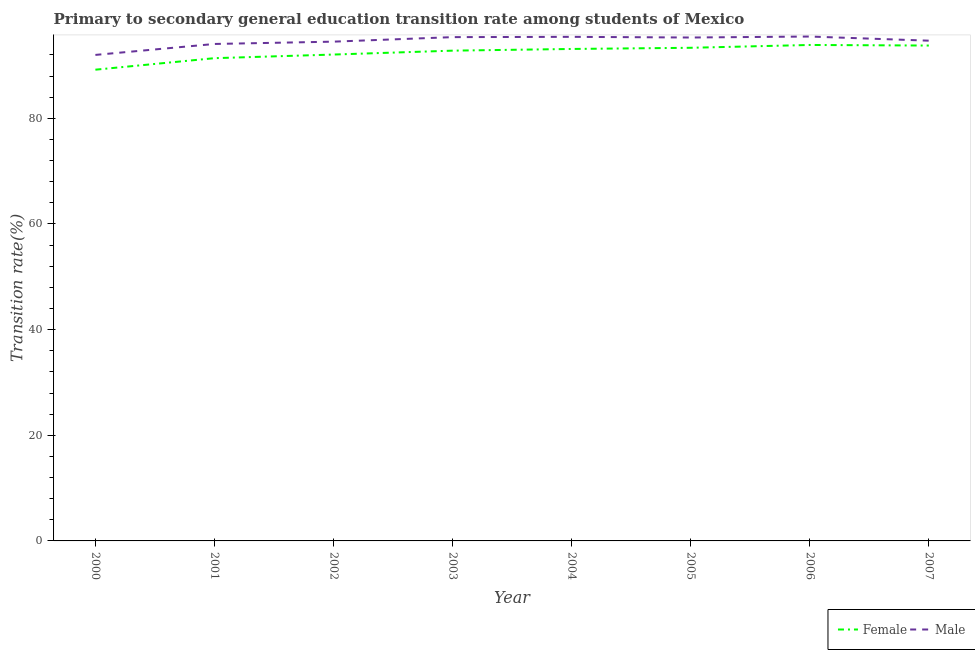Does the line corresponding to transition rate among male students intersect with the line corresponding to transition rate among female students?
Ensure brevity in your answer.  No. What is the transition rate among female students in 2001?
Provide a succinct answer. 91.39. Across all years, what is the maximum transition rate among female students?
Offer a terse response. 93.89. Across all years, what is the minimum transition rate among female students?
Provide a succinct answer. 89.21. In which year was the transition rate among male students maximum?
Give a very brief answer. 2006. What is the total transition rate among female students in the graph?
Ensure brevity in your answer.  739.67. What is the difference between the transition rate among female students in 2004 and that in 2007?
Provide a succinct answer. -0.65. What is the difference between the transition rate among male students in 2004 and the transition rate among female students in 2001?
Your answer should be very brief. 4.04. What is the average transition rate among male students per year?
Provide a succinct answer. 94.61. In the year 2000, what is the difference between the transition rate among female students and transition rate among male students?
Your response must be concise. -2.8. What is the ratio of the transition rate among female students in 2002 to that in 2005?
Offer a very short reply. 0.99. Is the difference between the transition rate among female students in 2004 and 2007 greater than the difference between the transition rate among male students in 2004 and 2007?
Ensure brevity in your answer.  No. What is the difference between the highest and the second highest transition rate among male students?
Your answer should be compact. 0.06. What is the difference between the highest and the lowest transition rate among female students?
Provide a succinct answer. 4.68. In how many years, is the transition rate among male students greater than the average transition rate among male students taken over all years?
Give a very brief answer. 5. Does the transition rate among female students monotonically increase over the years?
Your answer should be compact. No. What is the difference between two consecutive major ticks on the Y-axis?
Give a very brief answer. 20. Does the graph contain grids?
Your answer should be very brief. No. Where does the legend appear in the graph?
Keep it short and to the point. Bottom right. How many legend labels are there?
Make the answer very short. 2. What is the title of the graph?
Keep it short and to the point. Primary to secondary general education transition rate among students of Mexico. Does "Secondary" appear as one of the legend labels in the graph?
Provide a succinct answer. No. What is the label or title of the X-axis?
Keep it short and to the point. Year. What is the label or title of the Y-axis?
Offer a very short reply. Transition rate(%). What is the Transition rate(%) of Female in 2000?
Ensure brevity in your answer.  89.21. What is the Transition rate(%) in Male in 2000?
Provide a succinct answer. 92.01. What is the Transition rate(%) in Female in 2001?
Make the answer very short. 91.39. What is the Transition rate(%) in Male in 2001?
Give a very brief answer. 94.08. What is the Transition rate(%) in Female in 2002?
Provide a short and direct response. 92.08. What is the Transition rate(%) in Male in 2002?
Keep it short and to the point. 94.52. What is the Transition rate(%) in Female in 2003?
Ensure brevity in your answer.  92.82. What is the Transition rate(%) in Male in 2003?
Provide a short and direct response. 95.38. What is the Transition rate(%) in Female in 2004?
Ensure brevity in your answer.  93.14. What is the Transition rate(%) in Male in 2004?
Your answer should be compact. 95.43. What is the Transition rate(%) in Female in 2005?
Ensure brevity in your answer.  93.36. What is the Transition rate(%) of Male in 2005?
Offer a terse response. 95.3. What is the Transition rate(%) in Female in 2006?
Ensure brevity in your answer.  93.89. What is the Transition rate(%) of Male in 2006?
Your answer should be compact. 95.49. What is the Transition rate(%) in Female in 2007?
Your response must be concise. 93.78. What is the Transition rate(%) in Male in 2007?
Make the answer very short. 94.7. Across all years, what is the maximum Transition rate(%) in Female?
Give a very brief answer. 93.89. Across all years, what is the maximum Transition rate(%) of Male?
Provide a succinct answer. 95.49. Across all years, what is the minimum Transition rate(%) in Female?
Your answer should be very brief. 89.21. Across all years, what is the minimum Transition rate(%) in Male?
Your response must be concise. 92.01. What is the total Transition rate(%) in Female in the graph?
Offer a very short reply. 739.66. What is the total Transition rate(%) of Male in the graph?
Your answer should be very brief. 756.91. What is the difference between the Transition rate(%) in Female in 2000 and that in 2001?
Make the answer very short. -2.18. What is the difference between the Transition rate(%) of Male in 2000 and that in 2001?
Your answer should be very brief. -2.07. What is the difference between the Transition rate(%) in Female in 2000 and that in 2002?
Provide a short and direct response. -2.87. What is the difference between the Transition rate(%) in Male in 2000 and that in 2002?
Provide a short and direct response. -2.51. What is the difference between the Transition rate(%) in Female in 2000 and that in 2003?
Ensure brevity in your answer.  -3.6. What is the difference between the Transition rate(%) of Male in 2000 and that in 2003?
Your response must be concise. -3.37. What is the difference between the Transition rate(%) of Female in 2000 and that in 2004?
Give a very brief answer. -3.92. What is the difference between the Transition rate(%) of Male in 2000 and that in 2004?
Your response must be concise. -3.42. What is the difference between the Transition rate(%) of Female in 2000 and that in 2005?
Offer a very short reply. -4.15. What is the difference between the Transition rate(%) in Male in 2000 and that in 2005?
Your answer should be very brief. -3.29. What is the difference between the Transition rate(%) of Female in 2000 and that in 2006?
Your response must be concise. -4.68. What is the difference between the Transition rate(%) in Male in 2000 and that in 2006?
Keep it short and to the point. -3.48. What is the difference between the Transition rate(%) in Female in 2000 and that in 2007?
Your response must be concise. -4.57. What is the difference between the Transition rate(%) in Male in 2000 and that in 2007?
Ensure brevity in your answer.  -2.69. What is the difference between the Transition rate(%) in Female in 2001 and that in 2002?
Offer a terse response. -0.69. What is the difference between the Transition rate(%) of Male in 2001 and that in 2002?
Your answer should be compact. -0.44. What is the difference between the Transition rate(%) in Female in 2001 and that in 2003?
Offer a very short reply. -1.42. What is the difference between the Transition rate(%) in Male in 2001 and that in 2003?
Make the answer very short. -1.29. What is the difference between the Transition rate(%) in Female in 2001 and that in 2004?
Give a very brief answer. -1.74. What is the difference between the Transition rate(%) in Male in 2001 and that in 2004?
Offer a very short reply. -1.35. What is the difference between the Transition rate(%) in Female in 2001 and that in 2005?
Provide a succinct answer. -1.97. What is the difference between the Transition rate(%) of Male in 2001 and that in 2005?
Offer a terse response. -1.22. What is the difference between the Transition rate(%) in Female in 2001 and that in 2006?
Ensure brevity in your answer.  -2.5. What is the difference between the Transition rate(%) in Male in 2001 and that in 2006?
Offer a very short reply. -1.41. What is the difference between the Transition rate(%) of Female in 2001 and that in 2007?
Ensure brevity in your answer.  -2.39. What is the difference between the Transition rate(%) of Male in 2001 and that in 2007?
Offer a very short reply. -0.62. What is the difference between the Transition rate(%) of Female in 2002 and that in 2003?
Your answer should be compact. -0.74. What is the difference between the Transition rate(%) of Male in 2002 and that in 2003?
Make the answer very short. -0.86. What is the difference between the Transition rate(%) in Female in 2002 and that in 2004?
Give a very brief answer. -1.06. What is the difference between the Transition rate(%) of Male in 2002 and that in 2004?
Your response must be concise. -0.91. What is the difference between the Transition rate(%) of Female in 2002 and that in 2005?
Your answer should be compact. -1.28. What is the difference between the Transition rate(%) of Male in 2002 and that in 2005?
Make the answer very short. -0.78. What is the difference between the Transition rate(%) in Female in 2002 and that in 2006?
Offer a very short reply. -1.81. What is the difference between the Transition rate(%) of Male in 2002 and that in 2006?
Make the answer very short. -0.97. What is the difference between the Transition rate(%) in Female in 2002 and that in 2007?
Give a very brief answer. -1.7. What is the difference between the Transition rate(%) of Male in 2002 and that in 2007?
Give a very brief answer. -0.18. What is the difference between the Transition rate(%) in Female in 2003 and that in 2004?
Your answer should be very brief. -0.32. What is the difference between the Transition rate(%) in Male in 2003 and that in 2004?
Keep it short and to the point. -0.05. What is the difference between the Transition rate(%) of Female in 2003 and that in 2005?
Keep it short and to the point. -0.54. What is the difference between the Transition rate(%) in Male in 2003 and that in 2005?
Provide a succinct answer. 0.07. What is the difference between the Transition rate(%) in Female in 2003 and that in 2006?
Your response must be concise. -1.08. What is the difference between the Transition rate(%) in Male in 2003 and that in 2006?
Ensure brevity in your answer.  -0.11. What is the difference between the Transition rate(%) in Female in 2003 and that in 2007?
Ensure brevity in your answer.  -0.97. What is the difference between the Transition rate(%) of Male in 2003 and that in 2007?
Give a very brief answer. 0.67. What is the difference between the Transition rate(%) of Female in 2004 and that in 2005?
Provide a short and direct response. -0.22. What is the difference between the Transition rate(%) of Male in 2004 and that in 2005?
Offer a very short reply. 0.13. What is the difference between the Transition rate(%) of Female in 2004 and that in 2006?
Give a very brief answer. -0.76. What is the difference between the Transition rate(%) in Male in 2004 and that in 2006?
Provide a short and direct response. -0.06. What is the difference between the Transition rate(%) in Female in 2004 and that in 2007?
Offer a terse response. -0.65. What is the difference between the Transition rate(%) in Male in 2004 and that in 2007?
Your answer should be compact. 0.73. What is the difference between the Transition rate(%) in Female in 2005 and that in 2006?
Offer a very short reply. -0.53. What is the difference between the Transition rate(%) in Male in 2005 and that in 2006?
Your answer should be very brief. -0.19. What is the difference between the Transition rate(%) in Female in 2005 and that in 2007?
Make the answer very short. -0.42. What is the difference between the Transition rate(%) in Male in 2005 and that in 2007?
Your answer should be very brief. 0.6. What is the difference between the Transition rate(%) in Female in 2006 and that in 2007?
Offer a terse response. 0.11. What is the difference between the Transition rate(%) of Male in 2006 and that in 2007?
Provide a succinct answer. 0.78. What is the difference between the Transition rate(%) of Female in 2000 and the Transition rate(%) of Male in 2001?
Your answer should be very brief. -4.87. What is the difference between the Transition rate(%) of Female in 2000 and the Transition rate(%) of Male in 2002?
Your answer should be compact. -5.31. What is the difference between the Transition rate(%) in Female in 2000 and the Transition rate(%) in Male in 2003?
Ensure brevity in your answer.  -6.16. What is the difference between the Transition rate(%) in Female in 2000 and the Transition rate(%) in Male in 2004?
Make the answer very short. -6.22. What is the difference between the Transition rate(%) in Female in 2000 and the Transition rate(%) in Male in 2005?
Ensure brevity in your answer.  -6.09. What is the difference between the Transition rate(%) in Female in 2000 and the Transition rate(%) in Male in 2006?
Your answer should be very brief. -6.28. What is the difference between the Transition rate(%) of Female in 2000 and the Transition rate(%) of Male in 2007?
Offer a terse response. -5.49. What is the difference between the Transition rate(%) of Female in 2001 and the Transition rate(%) of Male in 2002?
Provide a succinct answer. -3.13. What is the difference between the Transition rate(%) of Female in 2001 and the Transition rate(%) of Male in 2003?
Your answer should be very brief. -3.98. What is the difference between the Transition rate(%) in Female in 2001 and the Transition rate(%) in Male in 2004?
Your response must be concise. -4.04. What is the difference between the Transition rate(%) in Female in 2001 and the Transition rate(%) in Male in 2005?
Keep it short and to the point. -3.91. What is the difference between the Transition rate(%) of Female in 2001 and the Transition rate(%) of Male in 2006?
Your answer should be very brief. -4.1. What is the difference between the Transition rate(%) of Female in 2001 and the Transition rate(%) of Male in 2007?
Your answer should be compact. -3.31. What is the difference between the Transition rate(%) of Female in 2002 and the Transition rate(%) of Male in 2003?
Offer a very short reply. -3.3. What is the difference between the Transition rate(%) of Female in 2002 and the Transition rate(%) of Male in 2004?
Offer a terse response. -3.35. What is the difference between the Transition rate(%) in Female in 2002 and the Transition rate(%) in Male in 2005?
Your answer should be very brief. -3.22. What is the difference between the Transition rate(%) of Female in 2002 and the Transition rate(%) of Male in 2006?
Offer a terse response. -3.41. What is the difference between the Transition rate(%) of Female in 2002 and the Transition rate(%) of Male in 2007?
Your answer should be compact. -2.63. What is the difference between the Transition rate(%) in Female in 2003 and the Transition rate(%) in Male in 2004?
Keep it short and to the point. -2.61. What is the difference between the Transition rate(%) of Female in 2003 and the Transition rate(%) of Male in 2005?
Keep it short and to the point. -2.49. What is the difference between the Transition rate(%) in Female in 2003 and the Transition rate(%) in Male in 2006?
Make the answer very short. -2.67. What is the difference between the Transition rate(%) in Female in 2003 and the Transition rate(%) in Male in 2007?
Make the answer very short. -1.89. What is the difference between the Transition rate(%) of Female in 2004 and the Transition rate(%) of Male in 2005?
Ensure brevity in your answer.  -2.17. What is the difference between the Transition rate(%) of Female in 2004 and the Transition rate(%) of Male in 2006?
Give a very brief answer. -2.35. What is the difference between the Transition rate(%) of Female in 2004 and the Transition rate(%) of Male in 2007?
Provide a succinct answer. -1.57. What is the difference between the Transition rate(%) of Female in 2005 and the Transition rate(%) of Male in 2006?
Give a very brief answer. -2.13. What is the difference between the Transition rate(%) in Female in 2005 and the Transition rate(%) in Male in 2007?
Provide a short and direct response. -1.35. What is the difference between the Transition rate(%) in Female in 2006 and the Transition rate(%) in Male in 2007?
Provide a short and direct response. -0.81. What is the average Transition rate(%) in Female per year?
Ensure brevity in your answer.  92.46. What is the average Transition rate(%) of Male per year?
Your answer should be very brief. 94.61. In the year 2000, what is the difference between the Transition rate(%) of Female and Transition rate(%) of Male?
Your response must be concise. -2.8. In the year 2001, what is the difference between the Transition rate(%) in Female and Transition rate(%) in Male?
Your answer should be compact. -2.69. In the year 2002, what is the difference between the Transition rate(%) of Female and Transition rate(%) of Male?
Offer a terse response. -2.44. In the year 2003, what is the difference between the Transition rate(%) of Female and Transition rate(%) of Male?
Keep it short and to the point. -2.56. In the year 2004, what is the difference between the Transition rate(%) of Female and Transition rate(%) of Male?
Provide a short and direct response. -2.29. In the year 2005, what is the difference between the Transition rate(%) in Female and Transition rate(%) in Male?
Offer a very short reply. -1.95. In the year 2006, what is the difference between the Transition rate(%) of Female and Transition rate(%) of Male?
Your answer should be compact. -1.6. In the year 2007, what is the difference between the Transition rate(%) of Female and Transition rate(%) of Male?
Ensure brevity in your answer.  -0.92. What is the ratio of the Transition rate(%) of Female in 2000 to that in 2001?
Offer a terse response. 0.98. What is the ratio of the Transition rate(%) in Female in 2000 to that in 2002?
Ensure brevity in your answer.  0.97. What is the ratio of the Transition rate(%) in Male in 2000 to that in 2002?
Your response must be concise. 0.97. What is the ratio of the Transition rate(%) of Female in 2000 to that in 2003?
Make the answer very short. 0.96. What is the ratio of the Transition rate(%) in Male in 2000 to that in 2003?
Your answer should be compact. 0.96. What is the ratio of the Transition rate(%) of Female in 2000 to that in 2004?
Provide a short and direct response. 0.96. What is the ratio of the Transition rate(%) of Male in 2000 to that in 2004?
Keep it short and to the point. 0.96. What is the ratio of the Transition rate(%) of Female in 2000 to that in 2005?
Your response must be concise. 0.96. What is the ratio of the Transition rate(%) in Male in 2000 to that in 2005?
Your answer should be compact. 0.97. What is the ratio of the Transition rate(%) in Female in 2000 to that in 2006?
Keep it short and to the point. 0.95. What is the ratio of the Transition rate(%) of Male in 2000 to that in 2006?
Make the answer very short. 0.96. What is the ratio of the Transition rate(%) in Female in 2000 to that in 2007?
Provide a short and direct response. 0.95. What is the ratio of the Transition rate(%) in Male in 2000 to that in 2007?
Offer a very short reply. 0.97. What is the ratio of the Transition rate(%) of Male in 2001 to that in 2002?
Offer a terse response. 1. What is the ratio of the Transition rate(%) of Female in 2001 to that in 2003?
Give a very brief answer. 0.98. What is the ratio of the Transition rate(%) of Male in 2001 to that in 2003?
Make the answer very short. 0.99. What is the ratio of the Transition rate(%) of Female in 2001 to that in 2004?
Your answer should be very brief. 0.98. What is the ratio of the Transition rate(%) of Male in 2001 to that in 2004?
Provide a succinct answer. 0.99. What is the ratio of the Transition rate(%) of Female in 2001 to that in 2005?
Your answer should be very brief. 0.98. What is the ratio of the Transition rate(%) of Male in 2001 to that in 2005?
Provide a short and direct response. 0.99. What is the ratio of the Transition rate(%) in Female in 2001 to that in 2006?
Provide a succinct answer. 0.97. What is the ratio of the Transition rate(%) in Female in 2001 to that in 2007?
Offer a terse response. 0.97. What is the ratio of the Transition rate(%) in Male in 2001 to that in 2007?
Your answer should be very brief. 0.99. What is the ratio of the Transition rate(%) in Male in 2002 to that in 2003?
Make the answer very short. 0.99. What is the ratio of the Transition rate(%) of Female in 2002 to that in 2005?
Offer a very short reply. 0.99. What is the ratio of the Transition rate(%) of Female in 2002 to that in 2006?
Provide a short and direct response. 0.98. What is the ratio of the Transition rate(%) in Female in 2002 to that in 2007?
Keep it short and to the point. 0.98. What is the ratio of the Transition rate(%) in Male in 2002 to that in 2007?
Your answer should be compact. 1. What is the ratio of the Transition rate(%) of Male in 2003 to that in 2004?
Make the answer very short. 1. What is the ratio of the Transition rate(%) in Female in 2003 to that in 2006?
Your response must be concise. 0.99. What is the ratio of the Transition rate(%) of Male in 2003 to that in 2006?
Offer a terse response. 1. What is the ratio of the Transition rate(%) of Female in 2003 to that in 2007?
Provide a succinct answer. 0.99. What is the ratio of the Transition rate(%) of Male in 2003 to that in 2007?
Provide a succinct answer. 1.01. What is the ratio of the Transition rate(%) of Male in 2004 to that in 2007?
Give a very brief answer. 1.01. What is the ratio of the Transition rate(%) of Male in 2005 to that in 2006?
Your answer should be compact. 1. What is the ratio of the Transition rate(%) of Male in 2006 to that in 2007?
Offer a very short reply. 1.01. What is the difference between the highest and the second highest Transition rate(%) in Female?
Make the answer very short. 0.11. What is the difference between the highest and the second highest Transition rate(%) of Male?
Your response must be concise. 0.06. What is the difference between the highest and the lowest Transition rate(%) of Female?
Your answer should be very brief. 4.68. What is the difference between the highest and the lowest Transition rate(%) in Male?
Provide a short and direct response. 3.48. 